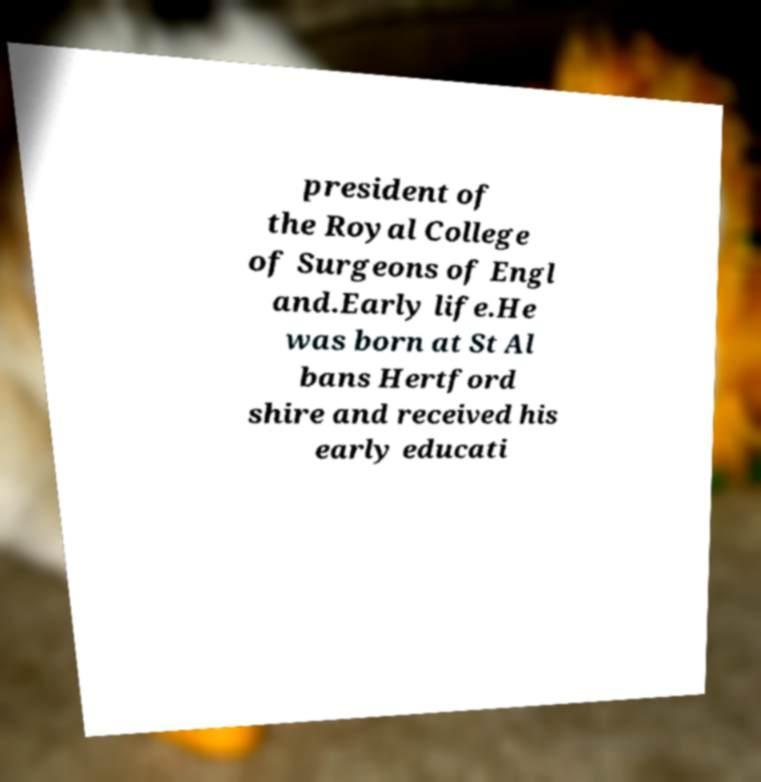What messages or text are displayed in this image? I need them in a readable, typed format. president of the Royal College of Surgeons of Engl and.Early life.He was born at St Al bans Hertford shire and received his early educati 